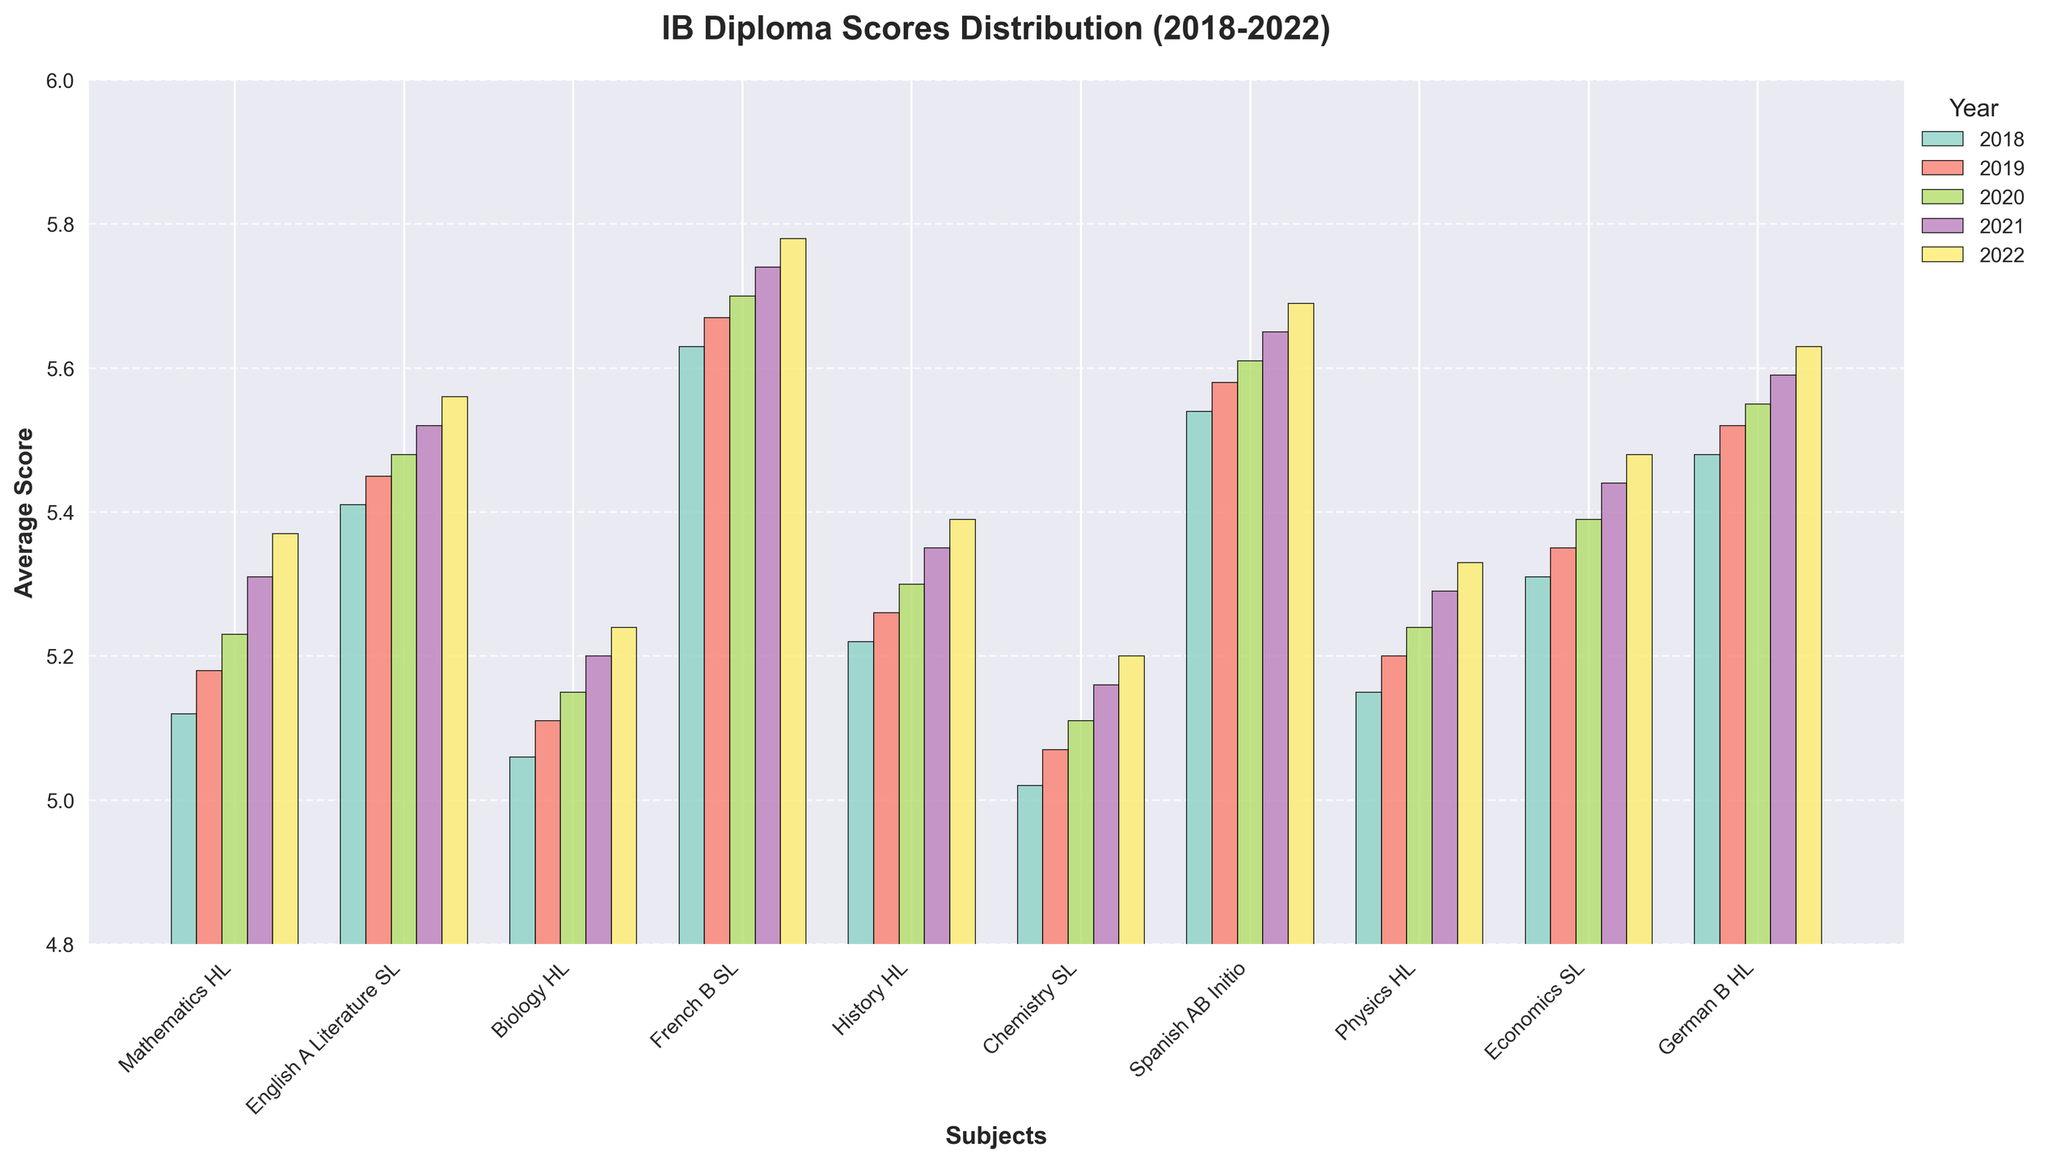Which subject had the highest average score in 2022? By looking at the heights of the bars for each subject in 2022, we can observe that French B SL has the tallest bar, indicating it had the highest average score in that year.
Answer: French B SL How did the scores for Chemistry SL change from 2018 to 2022? The scores for Chemistry SL were 5.02 in 2018, 5.07 in 2019, 5.11 in 2020, 5.16 in 2021, and 5.20 in 2022, indicating a consistent upward trend each year.
Answer: Increased consistently Which year showed the largest improvement in average scores for Economics SL? By comparing the height differences of the bars for Economics SL across the years, the largest improvement appears between 2020 and 2021, where scores increased from 5.39 to 5.44.
Answer: 2021 Compare the performance trends for Mathematics HL and Physics HL over the 5 years. Both subjects show an upward trend in average scores across the five years. Mathematics HL increased from 5.12 in 2018 to 5.37 in 2022, while Physics HL increased from 5.15 in 2018 to 5.33 in 2022.
Answer: Both increased, Mathematics HL by 0.25, Physics HL by 0.18 Which subject has the most stable scores from 2018 to 2022? By examining the bar heights for each subject, it appears that Spanish AB Initio had stable scores that only slightly changed each year: 5.54, 5.58, 5.61, 5.65, and 5.69.
Answer: Spanish AB Initio What is the average score of English A Literature SL for the five years? Average can be computed by summing the scores and dividing by the number of years. The scores are 5.41, 5.45, 5.48, 5.52, and 5.56. Sum is 27.42. Average is 27.42/5 = 5.484.
Answer: 5.484 Between 2018 and 2022, did any subject experience a decrease in its average score? By visually inspecting the figure, we notice that none of the subjects had a bar height that decreased over the years; they either increased or stayed the same.
Answer: No Compare the score increments of Biology HL and History HL from 2018 to 2022. Biology HL scores increased from 5.06 to 5.24, a difference of 0.18. History HL scores increased from 5.22 to 5.39, a difference of 0.17.
Answer: Biology HL increased by 0.18, History HL by 0.17 Which two subjects had the closest average scores in 2020? By visually comparing the bars in 2020, Chemistry SL and Biology HL had very close scores of 5.11 and 5.15, respectively.
Answer: Chemistry SL and Biology HL 